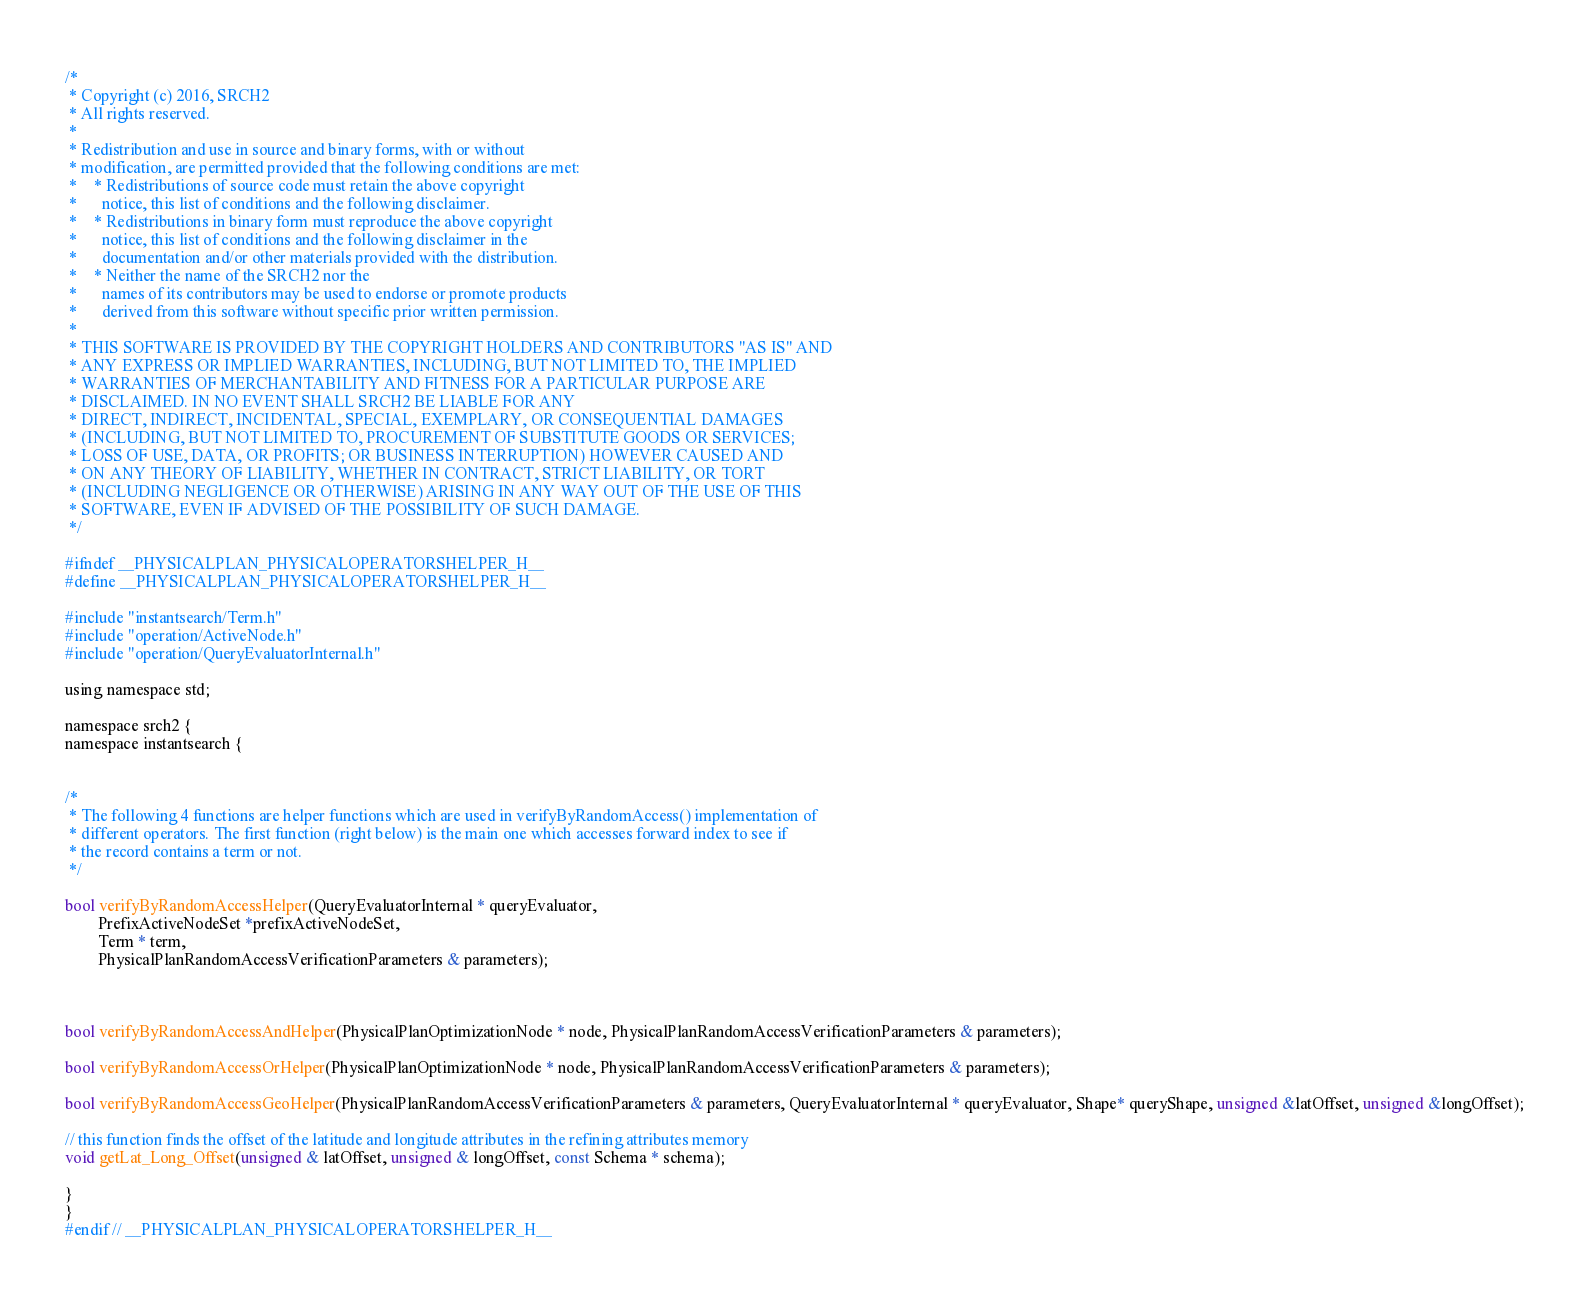Convert code to text. <code><loc_0><loc_0><loc_500><loc_500><_C_>/*
 * Copyright (c) 2016, SRCH2
 * All rights reserved.
 * 
 * Redistribution and use in source and binary forms, with or without
 * modification, are permitted provided that the following conditions are met:
 *    * Redistributions of source code must retain the above copyright
 *      notice, this list of conditions and the following disclaimer.
 *    * Redistributions in binary form must reproduce the above copyright
 *      notice, this list of conditions and the following disclaimer in the
 *      documentation and/or other materials provided with the distribution.
 *    * Neither the name of the SRCH2 nor the
 *      names of its contributors may be used to endorse or promote products
 *      derived from this software without specific prior written permission.
 * 
 * THIS SOFTWARE IS PROVIDED BY THE COPYRIGHT HOLDERS AND CONTRIBUTORS "AS IS" AND
 * ANY EXPRESS OR IMPLIED WARRANTIES, INCLUDING, BUT NOT LIMITED TO, THE IMPLIED
 * WARRANTIES OF MERCHANTABILITY AND FITNESS FOR A PARTICULAR PURPOSE ARE
 * DISCLAIMED. IN NO EVENT SHALL SRCH2 BE LIABLE FOR ANY
 * DIRECT, INDIRECT, INCIDENTAL, SPECIAL, EXEMPLARY, OR CONSEQUENTIAL DAMAGES
 * (INCLUDING, BUT NOT LIMITED TO, PROCUREMENT OF SUBSTITUTE GOODS OR SERVICES;
 * LOSS OF USE, DATA, OR PROFITS; OR BUSINESS INTERRUPTION) HOWEVER CAUSED AND
 * ON ANY THEORY OF LIABILITY, WHETHER IN CONTRACT, STRICT LIABILITY, OR TORT
 * (INCLUDING NEGLIGENCE OR OTHERWISE) ARISING IN ANY WAY OUT OF THE USE OF THIS
 * SOFTWARE, EVEN IF ADVISED OF THE POSSIBILITY OF SUCH DAMAGE.
 */

#ifndef __PHYSICALPLAN_PHYSICALOPERATORSHELPER_H__
#define __PHYSICALPLAN_PHYSICALOPERATORSHELPER_H__

#include "instantsearch/Term.h"
#include "operation/ActiveNode.h"
#include "operation/QueryEvaluatorInternal.h"

using namespace std;

namespace srch2 {
namespace instantsearch {


/*
 * The following 4 functions are helper functions which are used in verifyByRandomAccess() implementation of
 * different operators. The first function (right below) is the main one which accesses forward index to see if
 * the record contains a term or not.
 */

bool verifyByRandomAccessHelper(QueryEvaluatorInternal * queryEvaluator,
		PrefixActiveNodeSet *prefixActiveNodeSet,
		Term * term,
		PhysicalPlanRandomAccessVerificationParameters & parameters);



bool verifyByRandomAccessAndHelper(PhysicalPlanOptimizationNode * node, PhysicalPlanRandomAccessVerificationParameters & parameters);

bool verifyByRandomAccessOrHelper(PhysicalPlanOptimizationNode * node, PhysicalPlanRandomAccessVerificationParameters & parameters);

bool verifyByRandomAccessGeoHelper(PhysicalPlanRandomAccessVerificationParameters & parameters, QueryEvaluatorInternal * queryEvaluator, Shape* queryShape, unsigned &latOffset, unsigned &longOffset);

// this function finds the offset of the latitude and longitude attributes in the refining attributes memory
void getLat_Long_Offset(unsigned & latOffset, unsigned & longOffset, const Schema * schema);

}
}
#endif // __PHYSICALPLAN_PHYSICALOPERATORSHELPER_H__
</code> 